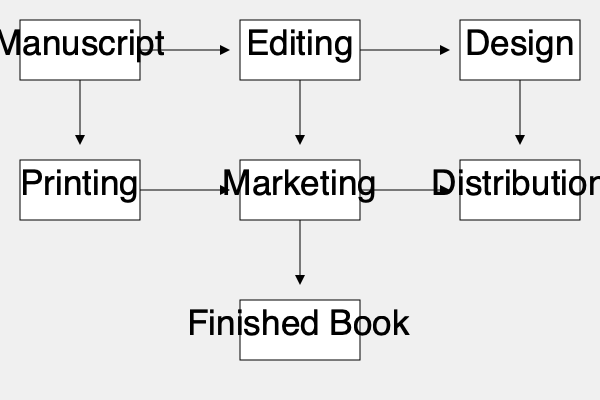In the publishing process flowchart, which step immediately follows the "Editing" stage? To answer this question, we need to follow the flow of the publishing process as shown in the flowchart:

1. The process begins with the "Manuscript" stage.
2. From the manuscript, an arrow leads to the "Editing" stage.
3. After the "Editing" stage, we can see an arrow pointing to the right, leading to the next step.
4. The stage immediately following "Editing" is "Design".

Therefore, in the publishing process flowchart, the step that immediately follows the "Editing" stage is the "Design" stage.

This sequence makes sense in the publishing industry, as the edited manuscript would typically move to the design phase, where the book's layout, cover design, and other visual elements are created.
Answer: Design 